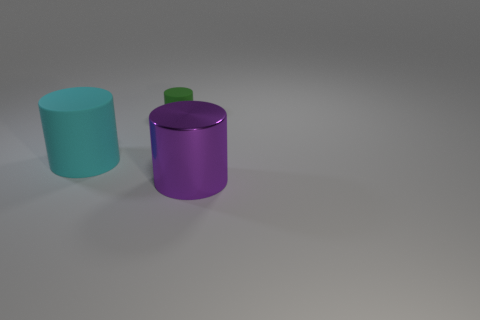Add 1 cyan objects. How many objects exist? 4 Add 2 large purple metallic things. How many large purple metallic things exist? 3 Subtract 1 green cylinders. How many objects are left? 2 Subtract all tiny green matte cylinders. Subtract all brown balls. How many objects are left? 2 Add 2 large cyan things. How many large cyan things are left? 3 